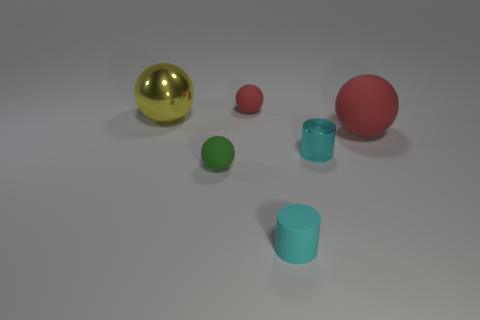Add 4 large brown shiny things. How many objects exist? 10 Subtract all balls. How many objects are left? 2 Add 4 big rubber cylinders. How many big rubber cylinders exist? 4 Subtract 0 blue blocks. How many objects are left? 6 Subtract all small green shiny cubes. Subtract all yellow balls. How many objects are left? 5 Add 1 big red rubber balls. How many big red rubber balls are left? 2 